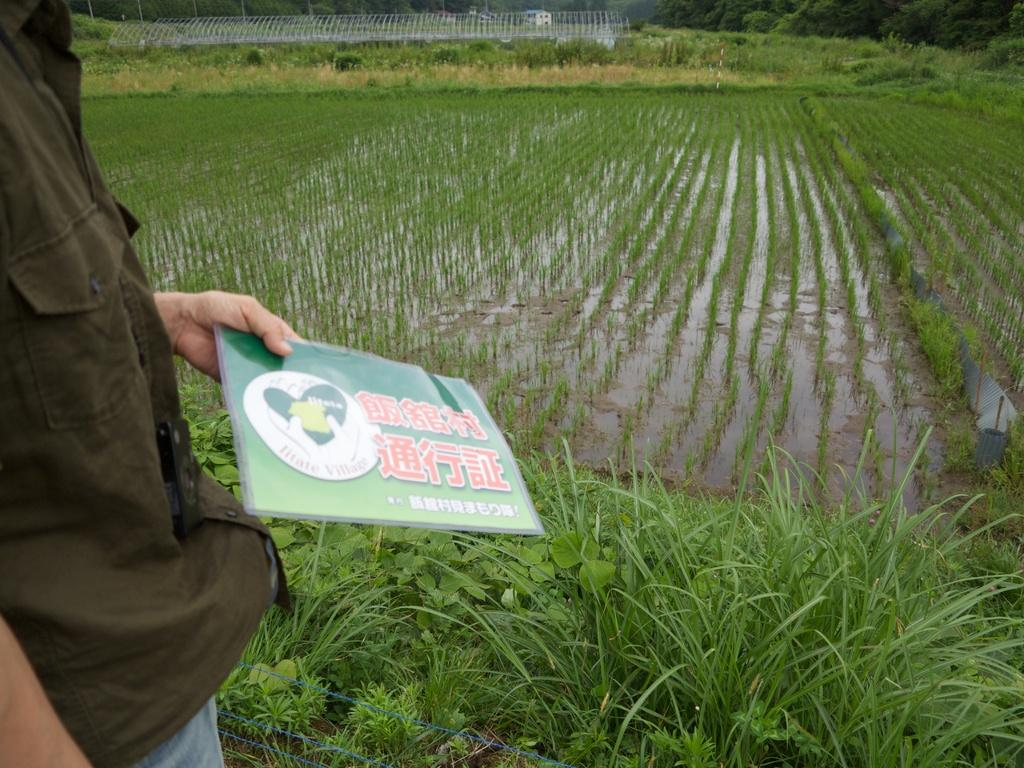What is the person in the image holding? The person is holding a book. What type of natural environment is visible in the image? There is grass visible in the image, and there are plants and trees in the background. What type of structure can be seen in the background of the image? There is a house in the background of the image. Can you see any fairies flying around the person holding the book in the image? There are no fairies visible in the image. Is there a sea visible in the background of the image? There is no sea present in the image; it features a house in the background. 